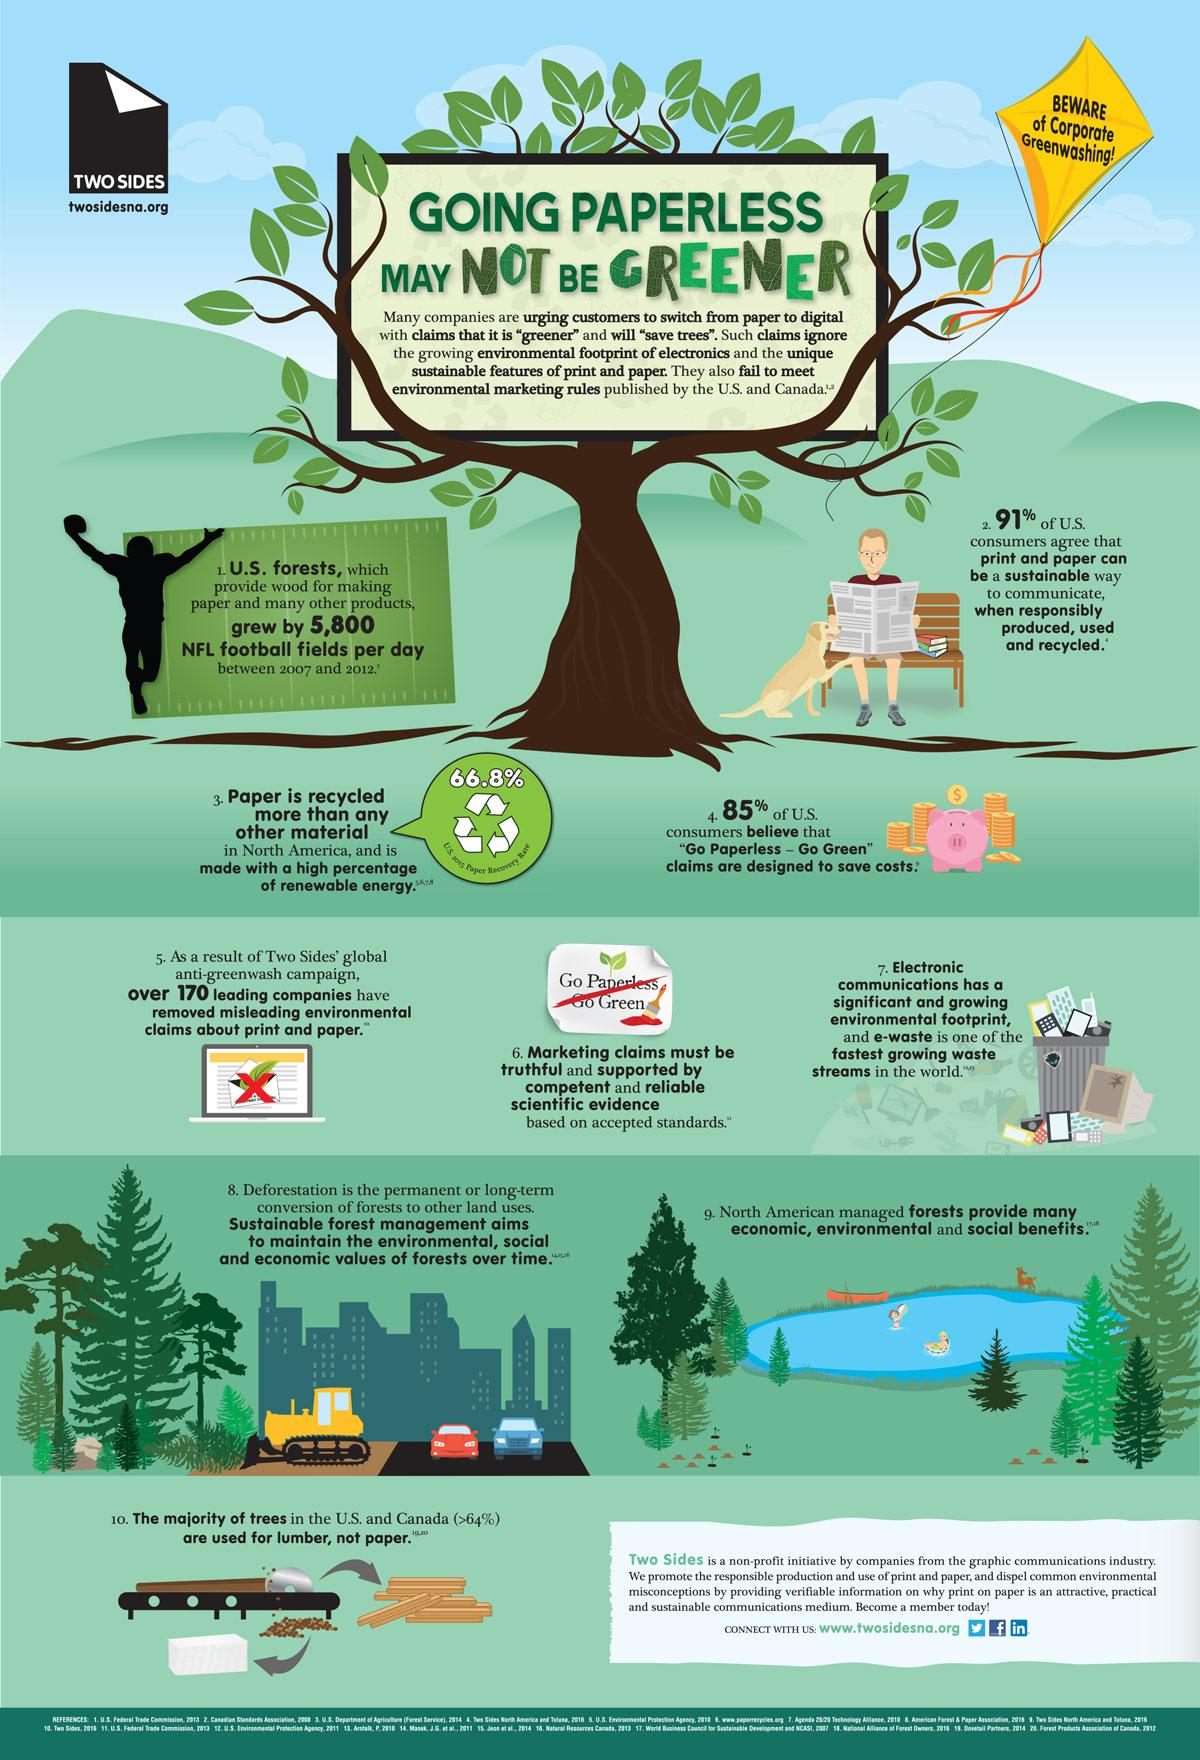Specify some key components in this picture. According to a recent survey, a small percentage of U.S. consumers, just 9%, do not believe that print and paper can be a sustainable way to communicate when responsibly produced, used, and recycled. In 2015, the paper recovery rate in the U.S. was 66.8%. According to a survey, 15% of U.S. consumers do not believe that the "Go Paperless - Go Green" claims are designed to save costs. 